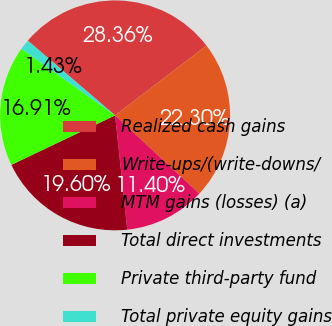Convert chart. <chart><loc_0><loc_0><loc_500><loc_500><pie_chart><fcel>Realized cash gains<fcel>Write-ups/(write-downs/<fcel>MTM gains (losses) (a)<fcel>Total direct investments<fcel>Private third-party fund<fcel>Total private equity gains<nl><fcel>28.36%<fcel>22.3%<fcel>11.4%<fcel>19.6%<fcel>16.91%<fcel>1.43%<nl></chart> 